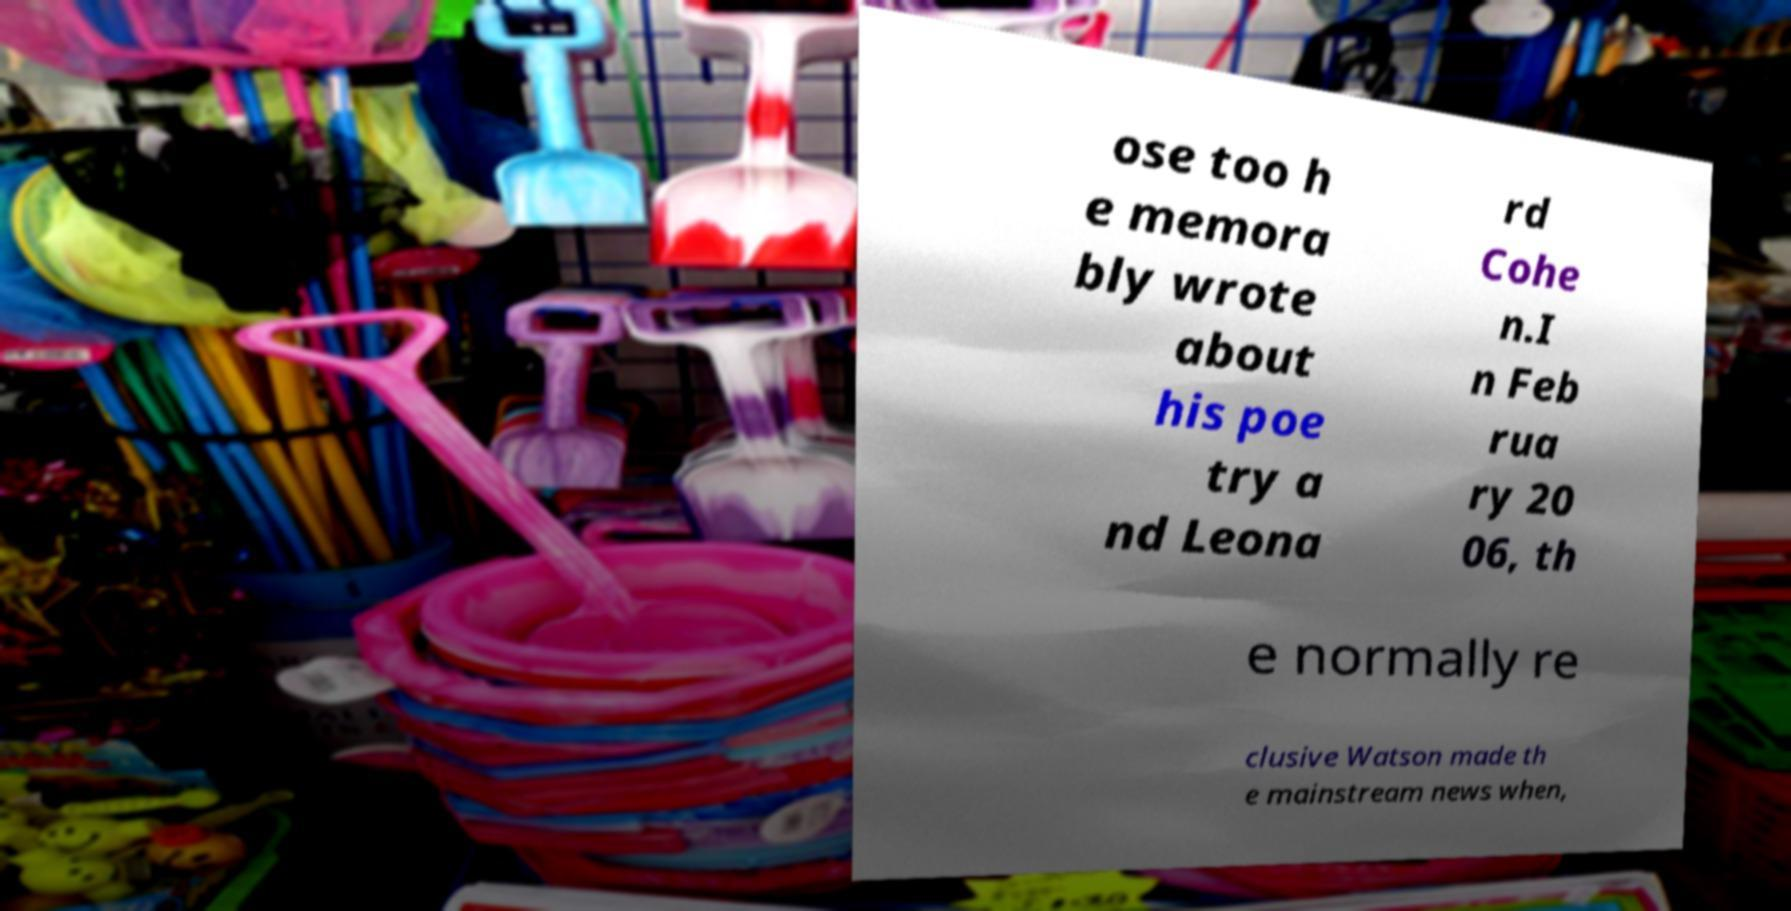I need the written content from this picture converted into text. Can you do that? ose too h e memora bly wrote about his poe try a nd Leona rd Cohe n.I n Feb rua ry 20 06, th e normally re clusive Watson made th e mainstream news when, 